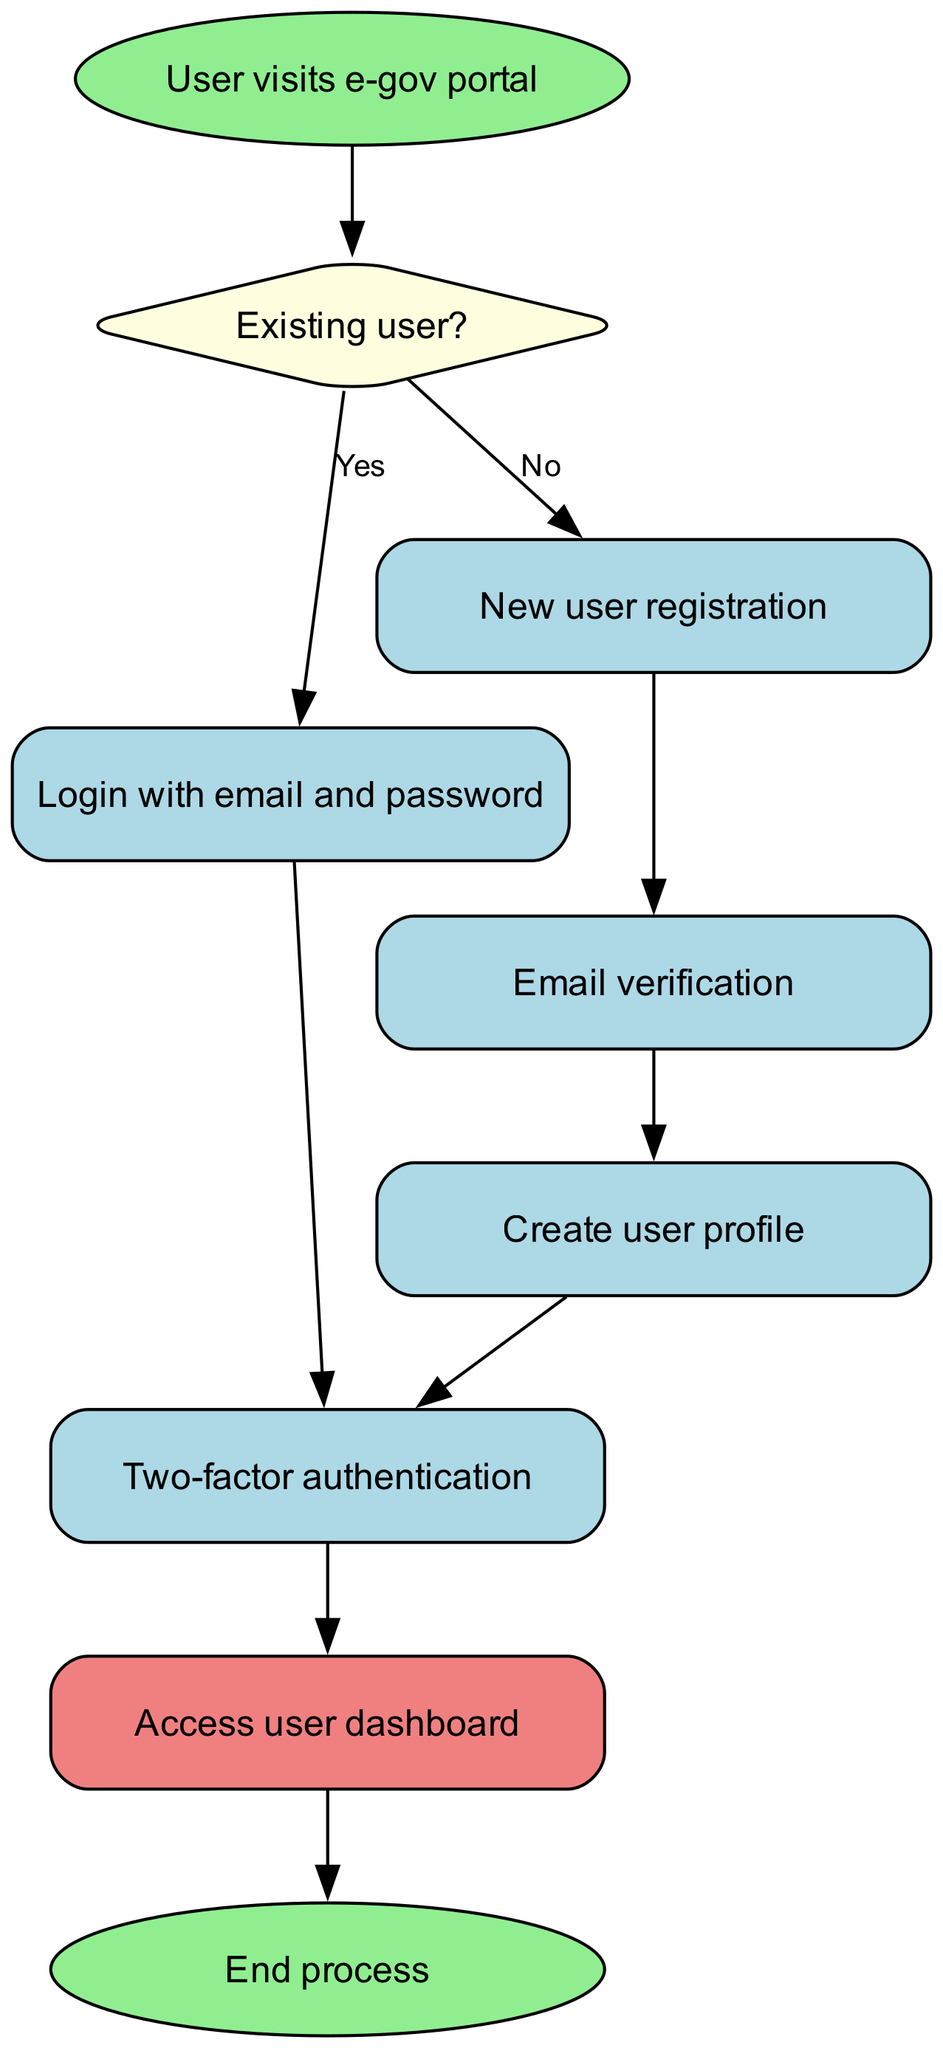What is the first action the user takes in the process? The diagram indicates that the user visits the e-gov portal as the initial action before any further steps are taken. This is represented by the "start" node.
Answer: User visits e-gov portal How many total nodes are present in the flowchart? By counting each unique node in the diagram, there are nine nodes including "start", "existing user", "login", "register", "verify email", "create profile", "two-factor authentication", "dashboard", and "end".
Answer: Nine What happens after an existing user logs in? According to the flowchart, after an existing user logs in, the next step is to go through two-factor authentication, which ensures that the user is verified before accessing the dashboard.
Answer: Two-factor authentication Which step follows email verification in the registration process? The diagram shows that following the "verify email" step, the user proceeds to create a user profile, indicating that successful email verification allows the user to move forward in the registration process.
Answer: Create user profile What type of node represents the decision point of whether a user is existing or new? The "existing user?" node is represented as a diamond shape in the diagram, signifying a decision point that leads to different subsequent actions based on the user’s status.
Answer: Diamond What is the last action before the process ends? According to the flowchart, the last action taken before the process concludes is accessing the user dashboard, which indicates that users have successfully logged in or registered.
Answer: Access user dashboard After creating a profile, which step must the user complete? The diagram indicates that once a user creates a profile, they must complete the two-factor authentication step to ensure their identity before accessing further services.
Answer: Two-factor authentication Is there a registration step for existing users? The flowchart clearly states that existing users skip the registration step and instead proceed directly to the login process, leading to two-factor authentication.
Answer: No How many edges are there in total connecting the nodes? By counting each of the relationships represented in the diagram, there are eight edges connecting the various actions from start to end, illustrating the flow of the registration and authentication process.
Answer: Eight 